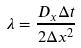Convert formula to latex. <formula><loc_0><loc_0><loc_500><loc_500>\lambda = \frac { D _ { x } \Delta t } { 2 \Delta x ^ { 2 } }</formula> 